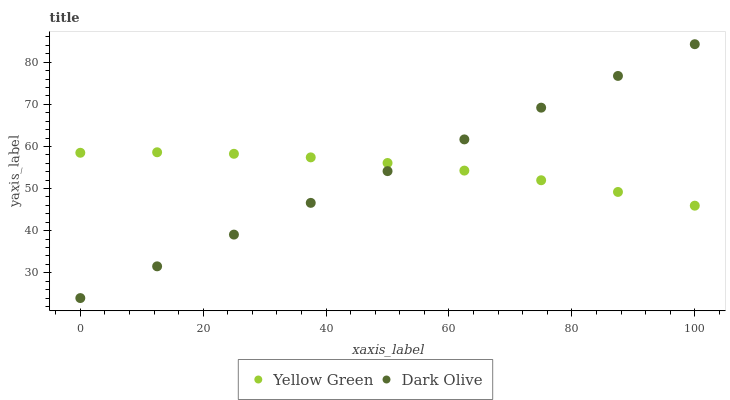Does Dark Olive have the minimum area under the curve?
Answer yes or no. Yes. Does Yellow Green have the maximum area under the curve?
Answer yes or no. Yes. Does Yellow Green have the minimum area under the curve?
Answer yes or no. No. Is Dark Olive the smoothest?
Answer yes or no. Yes. Is Yellow Green the roughest?
Answer yes or no. Yes. Is Yellow Green the smoothest?
Answer yes or no. No. Does Dark Olive have the lowest value?
Answer yes or no. Yes. Does Yellow Green have the lowest value?
Answer yes or no. No. Does Dark Olive have the highest value?
Answer yes or no. Yes. Does Yellow Green have the highest value?
Answer yes or no. No. Does Dark Olive intersect Yellow Green?
Answer yes or no. Yes. Is Dark Olive less than Yellow Green?
Answer yes or no. No. Is Dark Olive greater than Yellow Green?
Answer yes or no. No. 